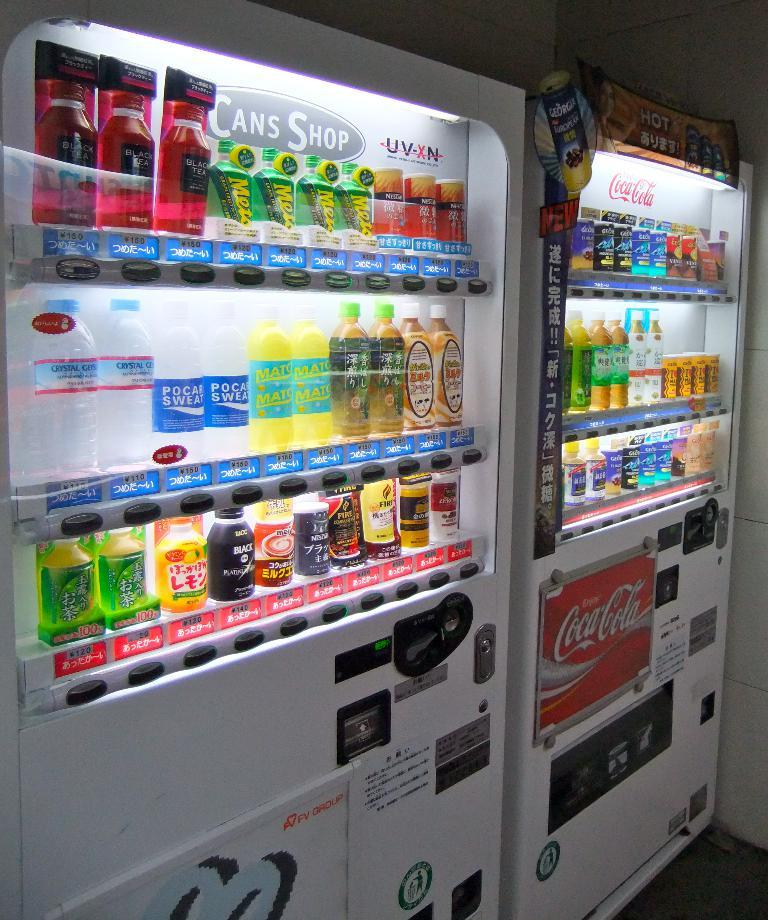<image>
Share a concise interpretation of the image provided. A couple of vending machines, one of which has a Coca Cola advert. 